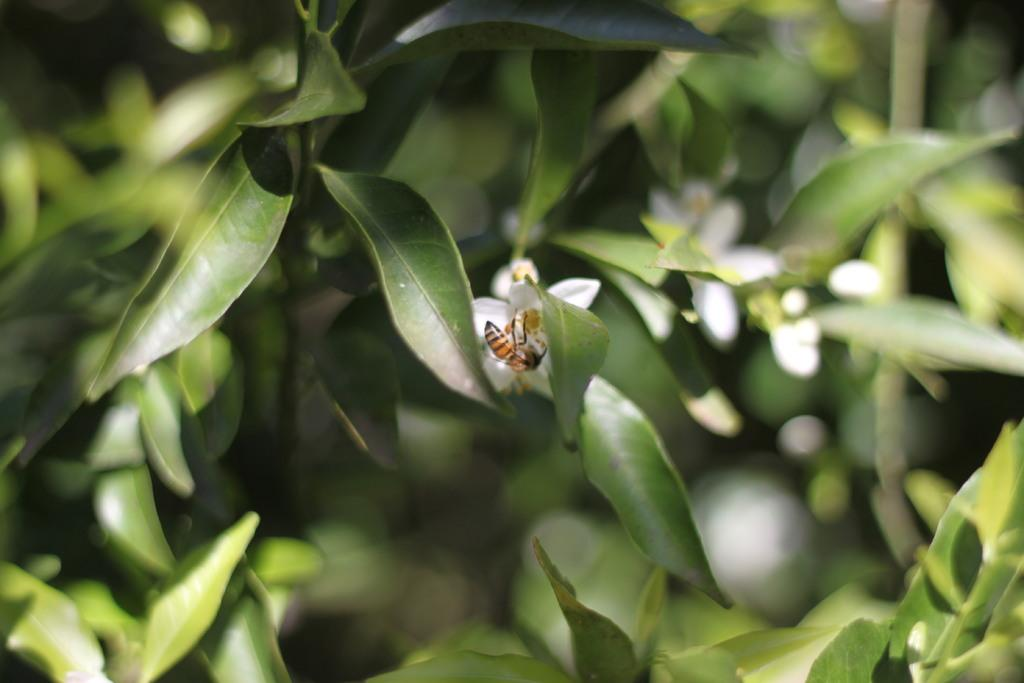What is on the flower in the image? There is a bee on a flower in the image. What can be seen in the background of the image? There are leaves visible in the background of the image. What degree does the kitten have in the image? There is no kitten present in the image, so it cannot have a degree. 